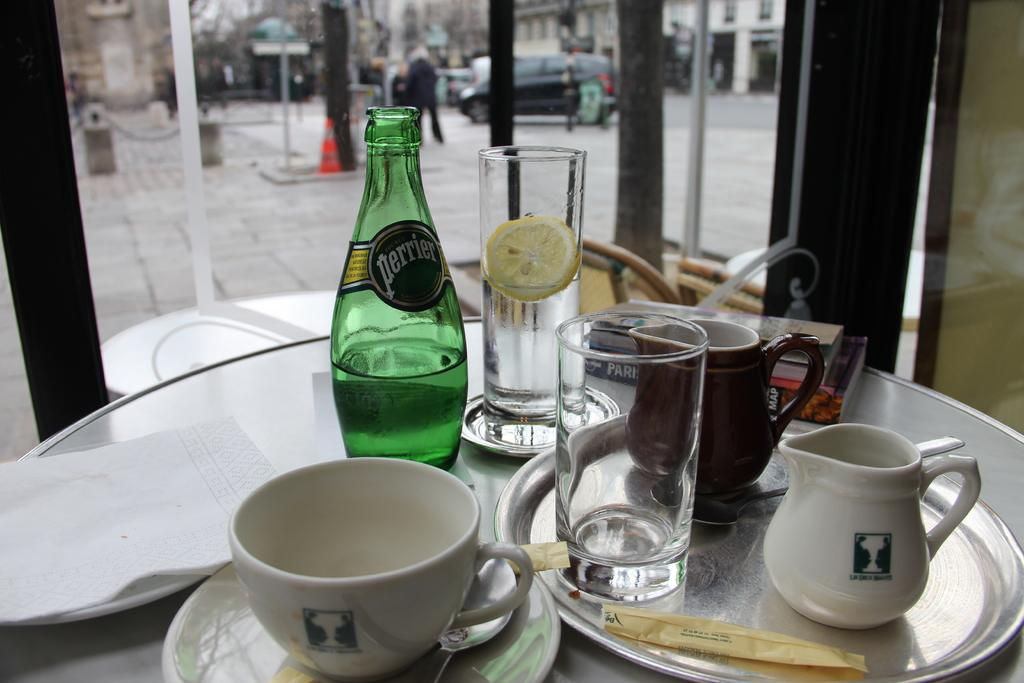What is on the table in the image? There is a glass, a bottle, and a plate on the table. Are there any other objects on the table? Yes, there are other objects on the table. What is happening in front of the table? A car is moving on the road in front of the table. What type of spoon is being used to stir the cream in the image? There is no spoon or cream present in the image. How many sticks are visible in the image? There are no sticks visible in the image. 